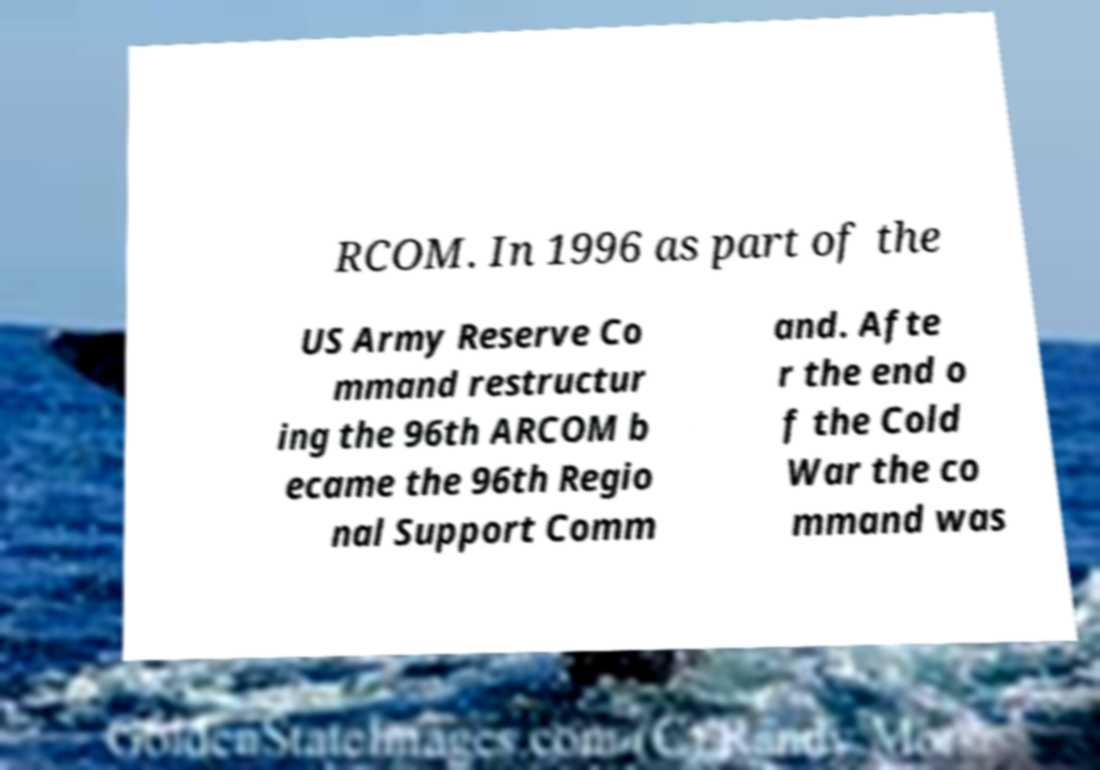Could you extract and type out the text from this image? RCOM. In 1996 as part of the US Army Reserve Co mmand restructur ing the 96th ARCOM b ecame the 96th Regio nal Support Comm and. Afte r the end o f the Cold War the co mmand was 